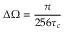<formula> <loc_0><loc_0><loc_500><loc_500>\Delta \Omega = \frac { \pi } { 2 5 6 \tau _ { c } }</formula> 